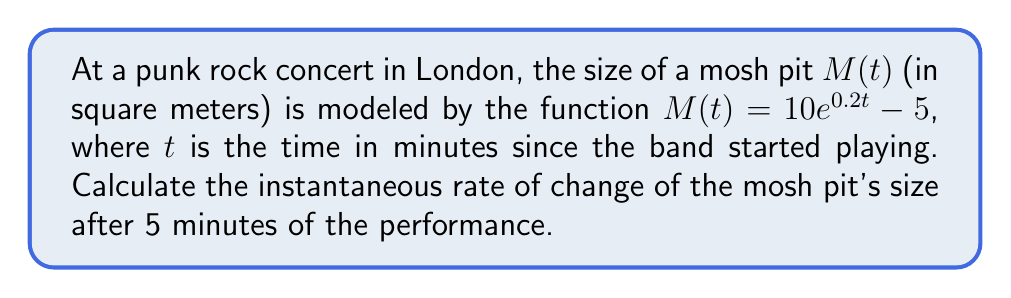Show me your answer to this math problem. To find the instantaneous rate of change of the mosh pit's size after 5 minutes, we need to calculate the derivative of $M(t)$ and evaluate it at $t=5$. Let's break this down step-by-step:

1) The given function is $M(t) = 10e^{0.2t} - 5$

2) To find the derivative, we use the chain rule:
   $$\frac{dM}{dt} = 10 \cdot 0.2 \cdot e^{0.2t} = 2e^{0.2t}$$

3) This derivative represents the instantaneous rate of change of the mosh pit's size at any time $t$.

4) To find the rate of change at $t=5$, we substitute $t=5$ into our derivative:
   $$\frac{dM}{dt}\Big|_{t=5} = 2e^{0.2(5)} = 2e^1 \approx 5.44$$

5) Therefore, after 5 minutes, the mosh pit is growing at a rate of approximately 5.44 square meters per minute.
Answer: $5.44$ m²/min 